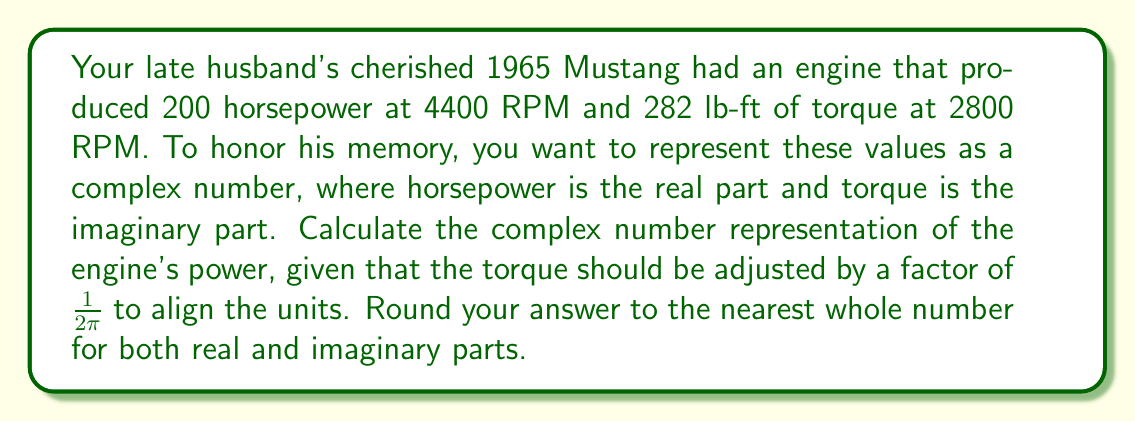Solve this math problem. To represent the engine's power as a complex number, we'll use the following steps:

1) The real part will be the horsepower: 200 HP

2) The imaginary part will be the torque, but we need to adjust it:
   
   Torque adjustment = $282 \times \frac{1}{2\pi}$ lb-ft
   
   $= 282 \times \frac{1}{2 \times 3.14159}$ lb-ft
   
   $\approx 44.86$ lb-ft

3) Now we can form our complex number:

   $z = 200 + 44.86i$

4) Rounding to the nearest whole number:

   $z \approx 200 + 45i$

This complex number representation combines both the horsepower (real part) and the adjusted torque (imaginary part) into a single entity, symbolizing the overall power characteristics of your late husband's beloved Mustang engine.
Answer: $z \approx 200 + 45i$ 